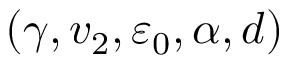<formula> <loc_0><loc_0><loc_500><loc_500>( \gamma , v _ { 2 } , \varepsilon _ { 0 } , \alpha , d )</formula> 